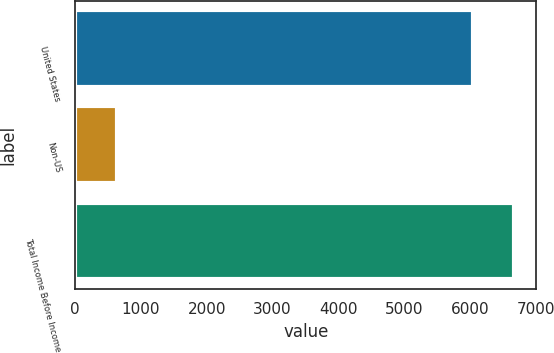<chart> <loc_0><loc_0><loc_500><loc_500><bar_chart><fcel>United States<fcel>Non-US<fcel>Total Income Before Income<nl><fcel>6040<fcel>634<fcel>6674<nl></chart> 